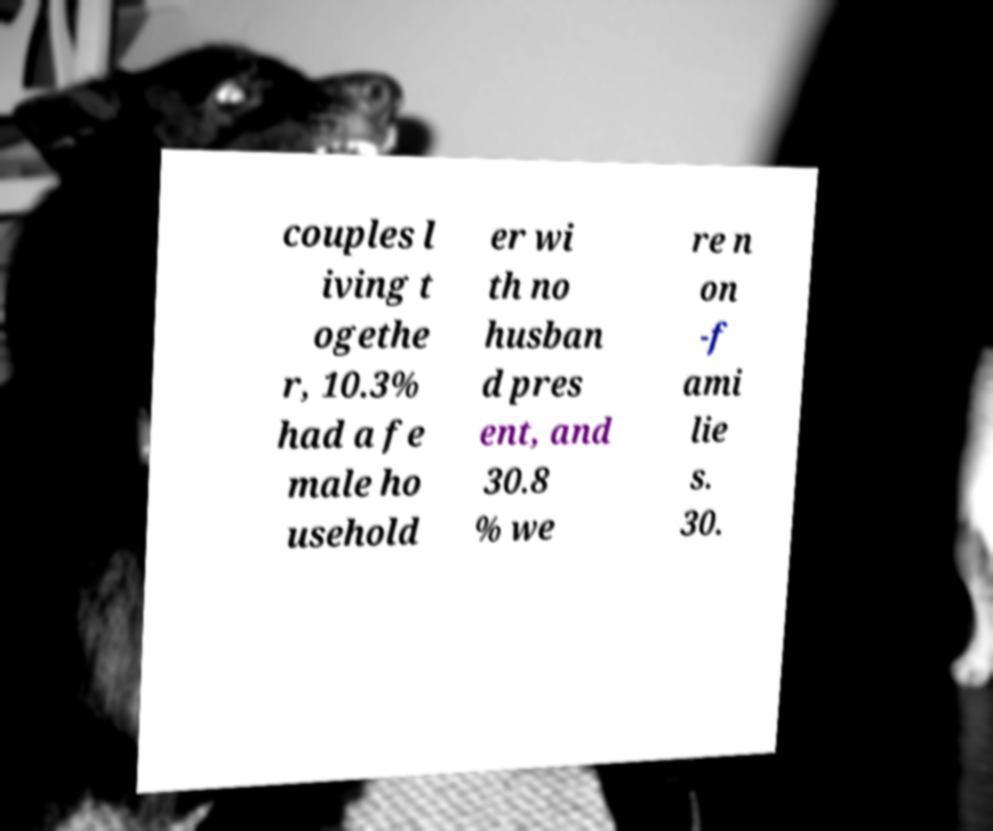Could you extract and type out the text from this image? couples l iving t ogethe r, 10.3% had a fe male ho usehold er wi th no husban d pres ent, and 30.8 % we re n on -f ami lie s. 30. 